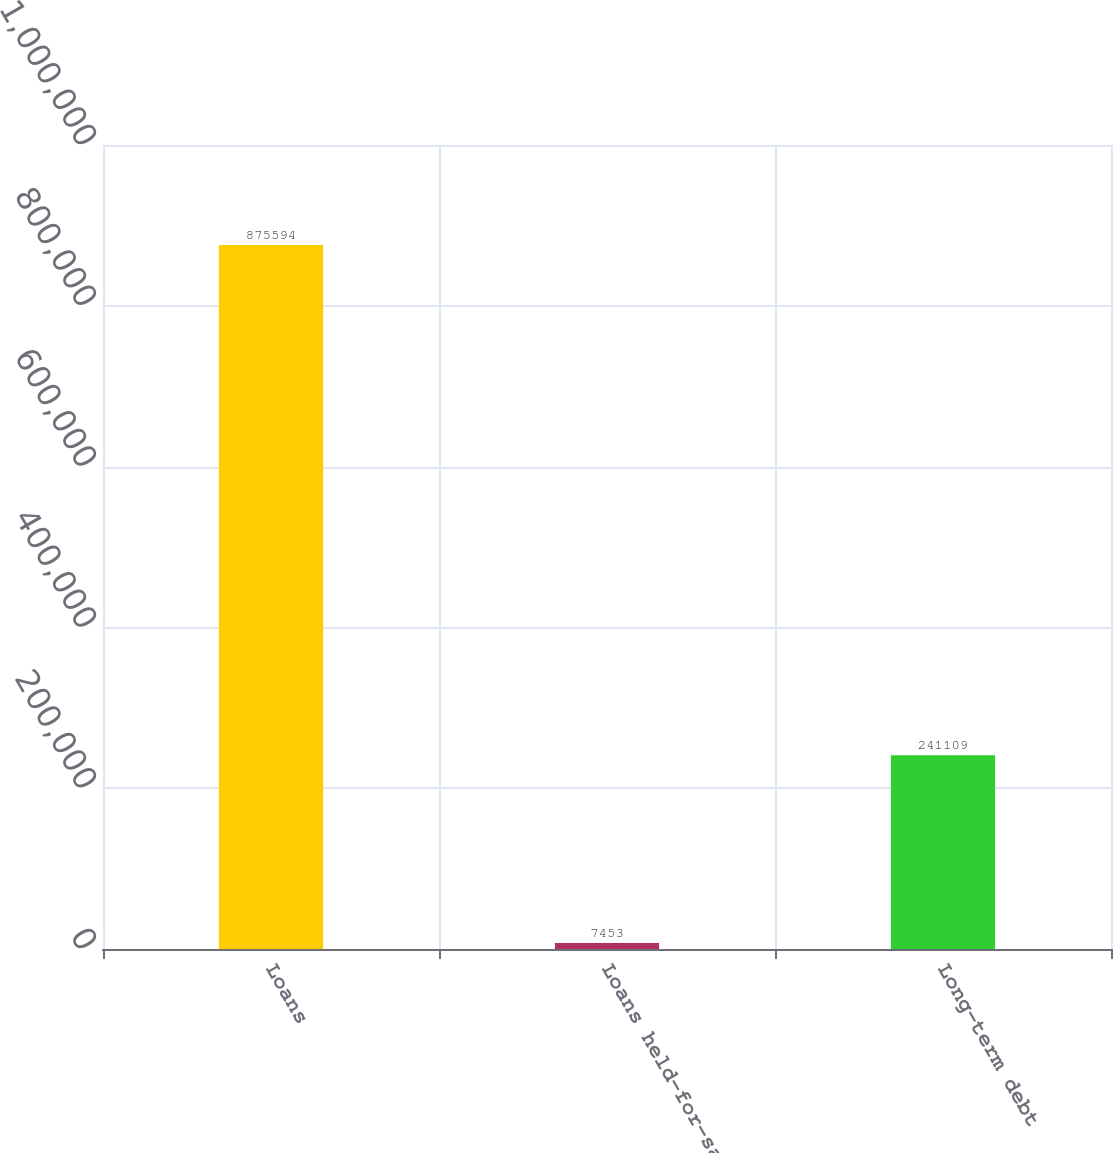Convert chart to OTSL. <chart><loc_0><loc_0><loc_500><loc_500><bar_chart><fcel>Loans<fcel>Loans held-for-sale<fcel>Long-term debt<nl><fcel>875594<fcel>7453<fcel>241109<nl></chart> 